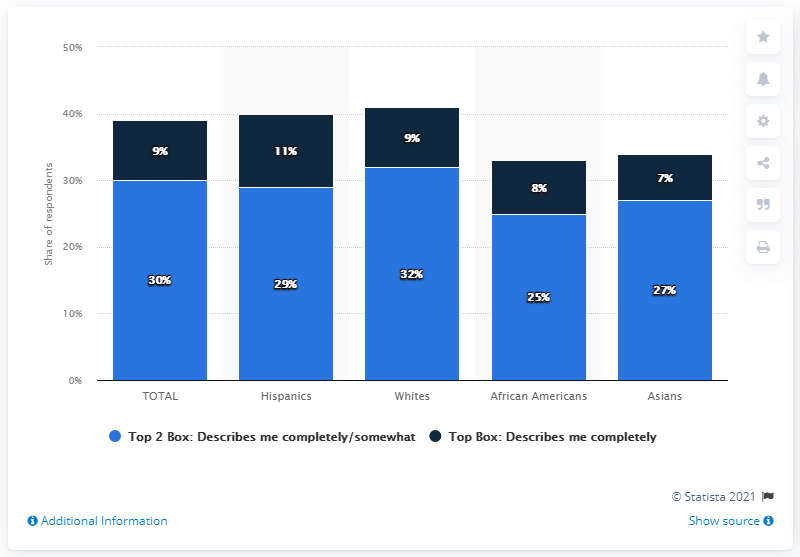Identify some key points in this picture. The value of the rightmost light blue bar is 27. Out of the four navy blue bars, 70% of them exceed the specified limit. 